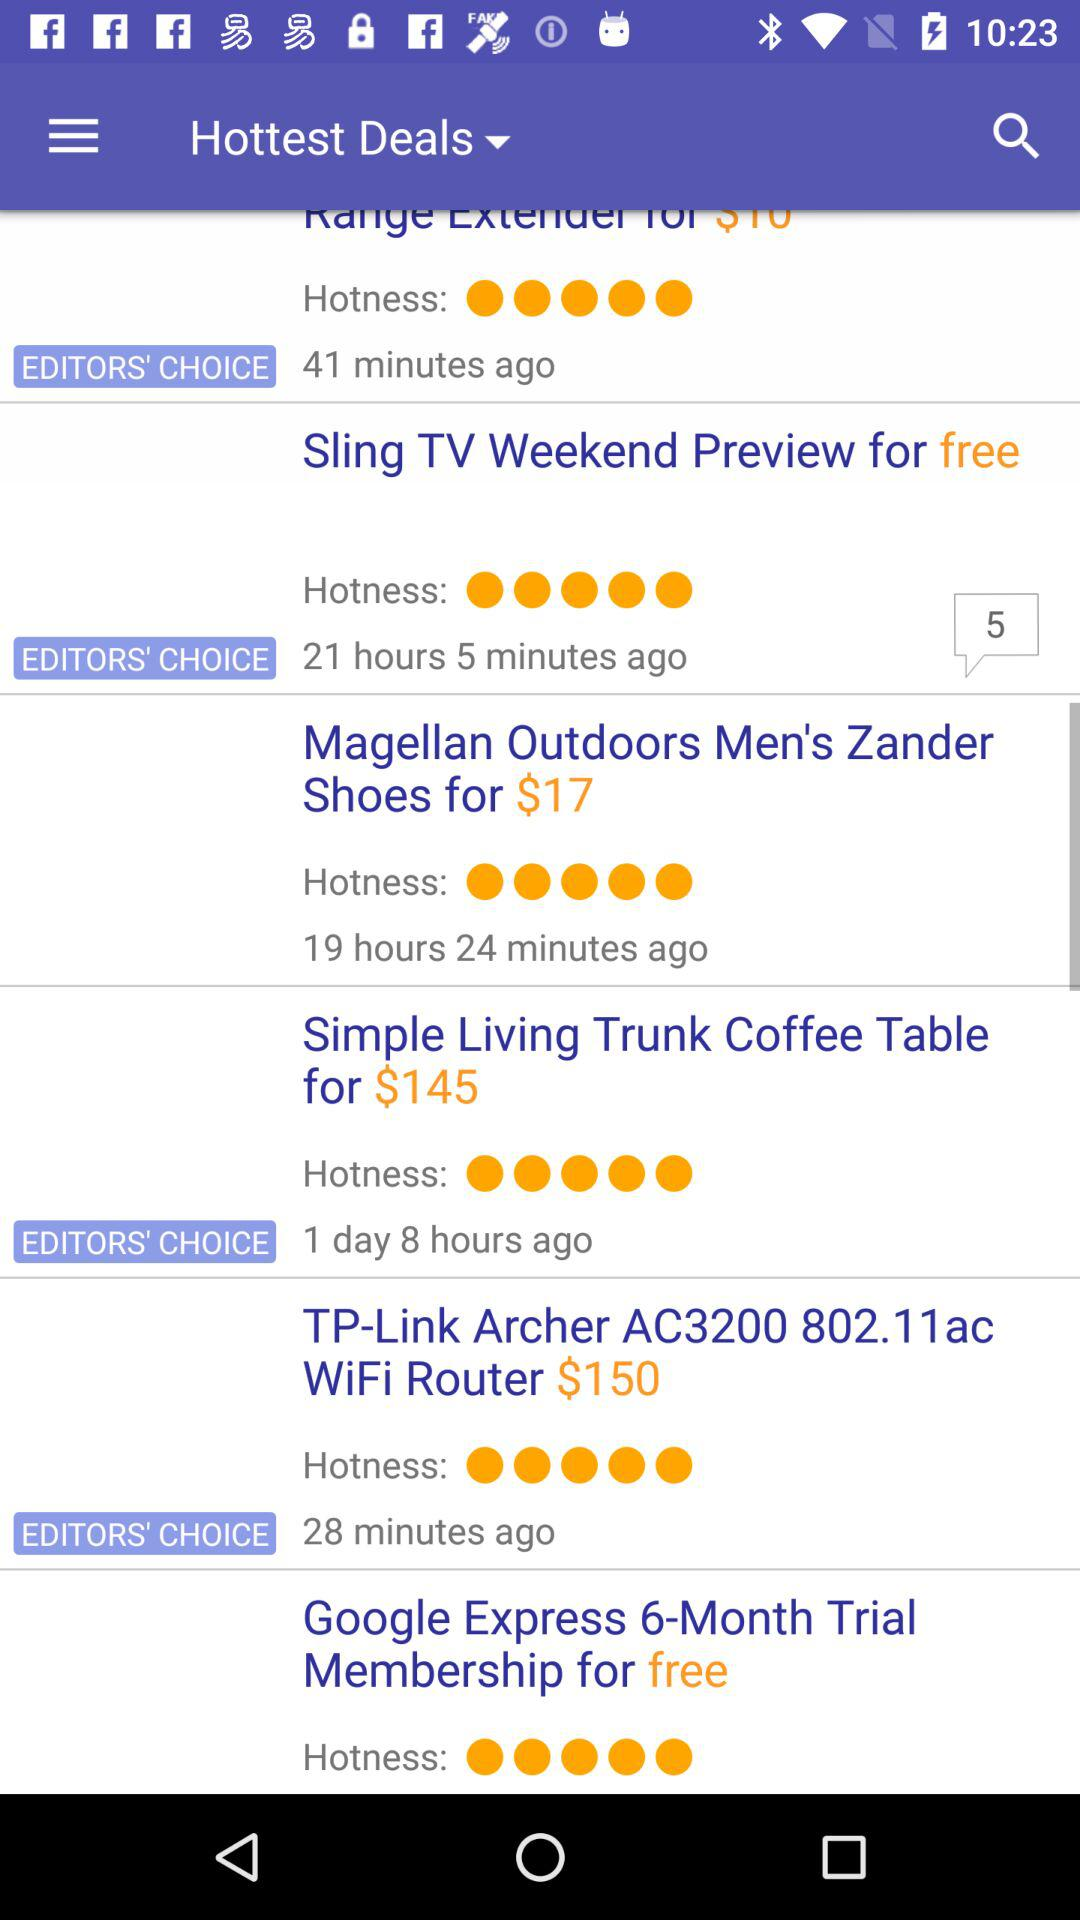Which deal is free of cost? The deals are "Sling TV Weekend Preview" and "Google Express 6-Month Trial Membership". 